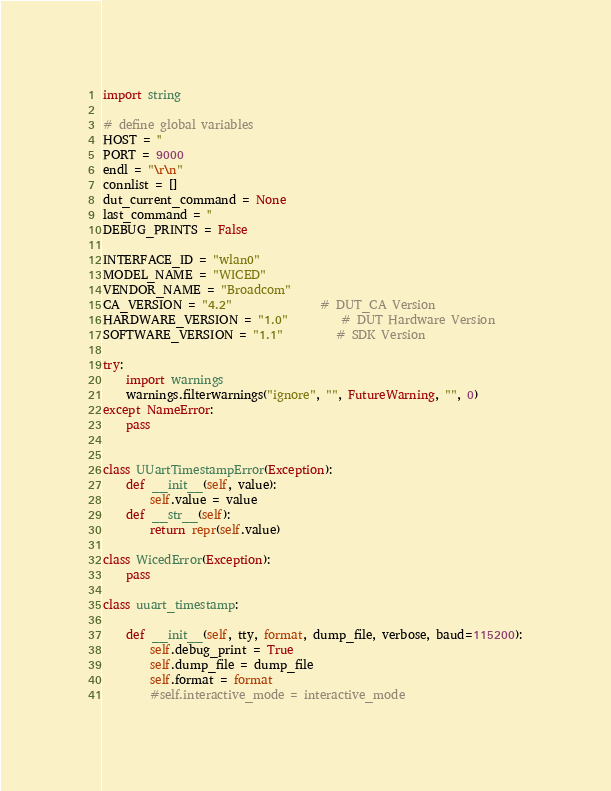<code> <loc_0><loc_0><loc_500><loc_500><_Python_>import string

# define global variables
HOST = ''
PORT = 9000
endl = "\r\n"
connlist = []
dut_current_command = None
last_command = ''
DEBUG_PRINTS = False

INTERFACE_ID = "wlan0"
MODEL_NAME = "WICED"
VENDOR_NAME = "Broadcom"
CA_VERSION = "4.2"               # DUT_CA Version
HARDWARE_VERSION = "1.0"         # DUT Hardware Version
SOFTWARE_VERSION = "1.1"         # SDK Version

try:
    import warnings
    warnings.filterwarnings("ignore", "", FutureWarning, "", 0)
except NameError:
    pass


class UUartTimestampError(Exception):
    def __init__(self, value):
        self.value = value
    def __str__(self):
        return repr(self.value)

class WicedError(Exception):
    pass

class uuart_timestamp:

    def __init__(self, tty, format, dump_file, verbose, baud=115200):
        self.debug_print = True
        self.dump_file = dump_file
        self.format = format
        #self.interactive_mode = interactive_mode</code> 